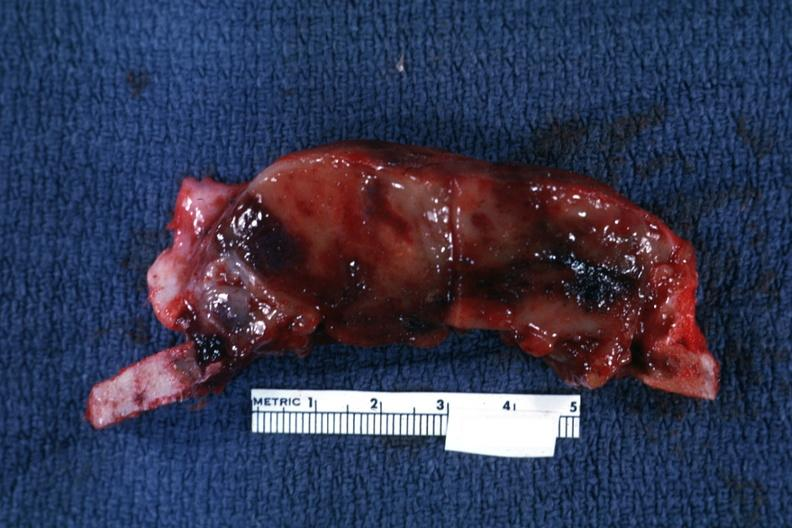what does this image show?
Answer the question using a single word or phrase. Section of calvarium 